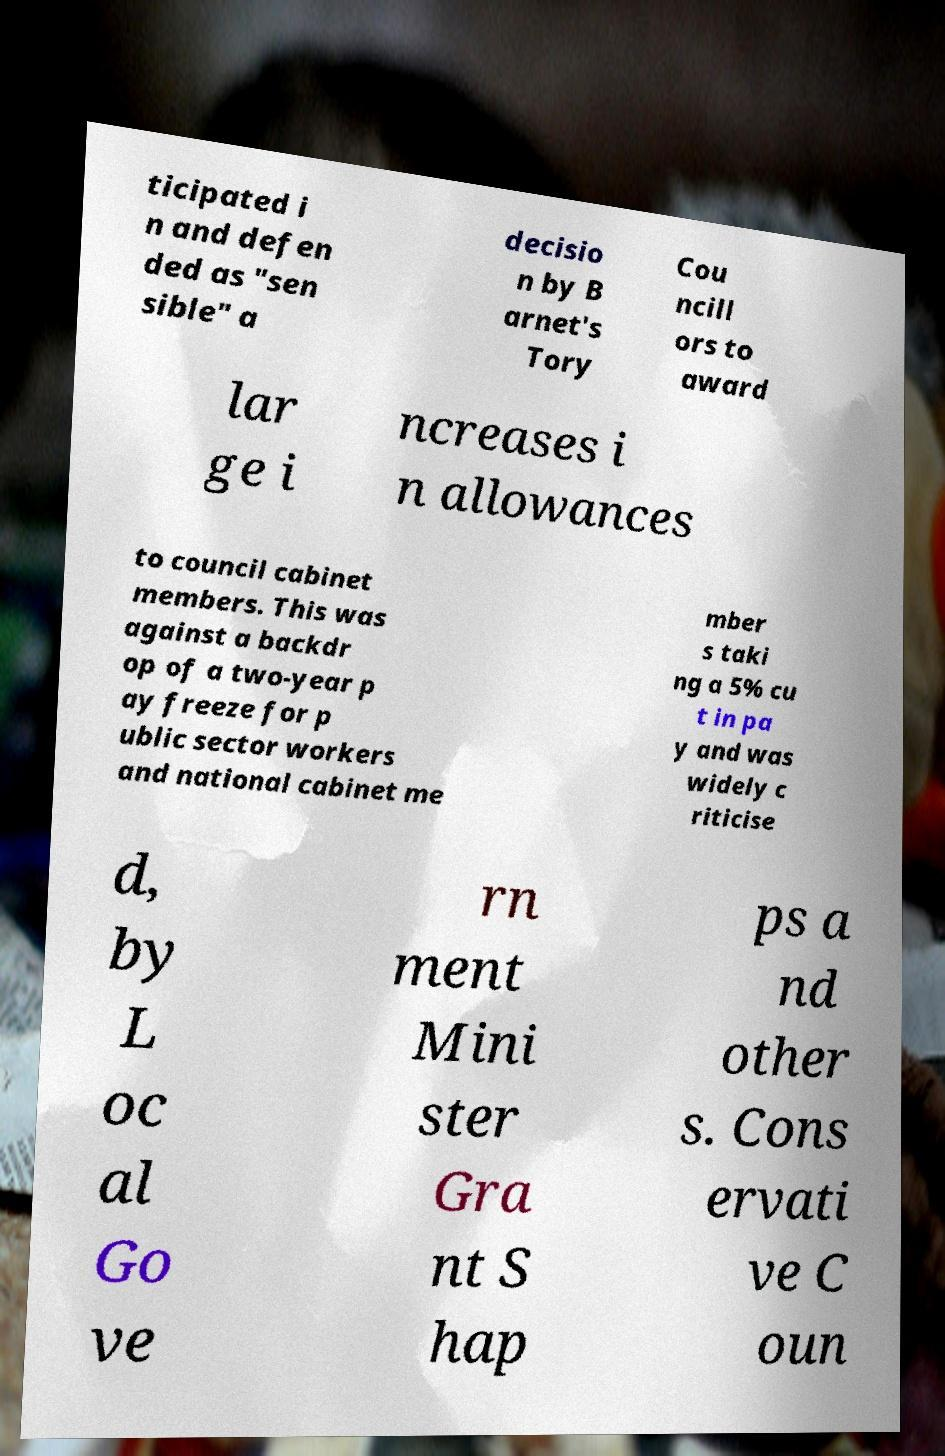There's text embedded in this image that I need extracted. Can you transcribe it verbatim? ticipated i n and defen ded as "sen sible" a decisio n by B arnet's Tory Cou ncill ors to award lar ge i ncreases i n allowances to council cabinet members. This was against a backdr op of a two-year p ay freeze for p ublic sector workers and national cabinet me mber s taki ng a 5% cu t in pa y and was widely c riticise d, by L oc al Go ve rn ment Mini ster Gra nt S hap ps a nd other s. Cons ervati ve C oun 